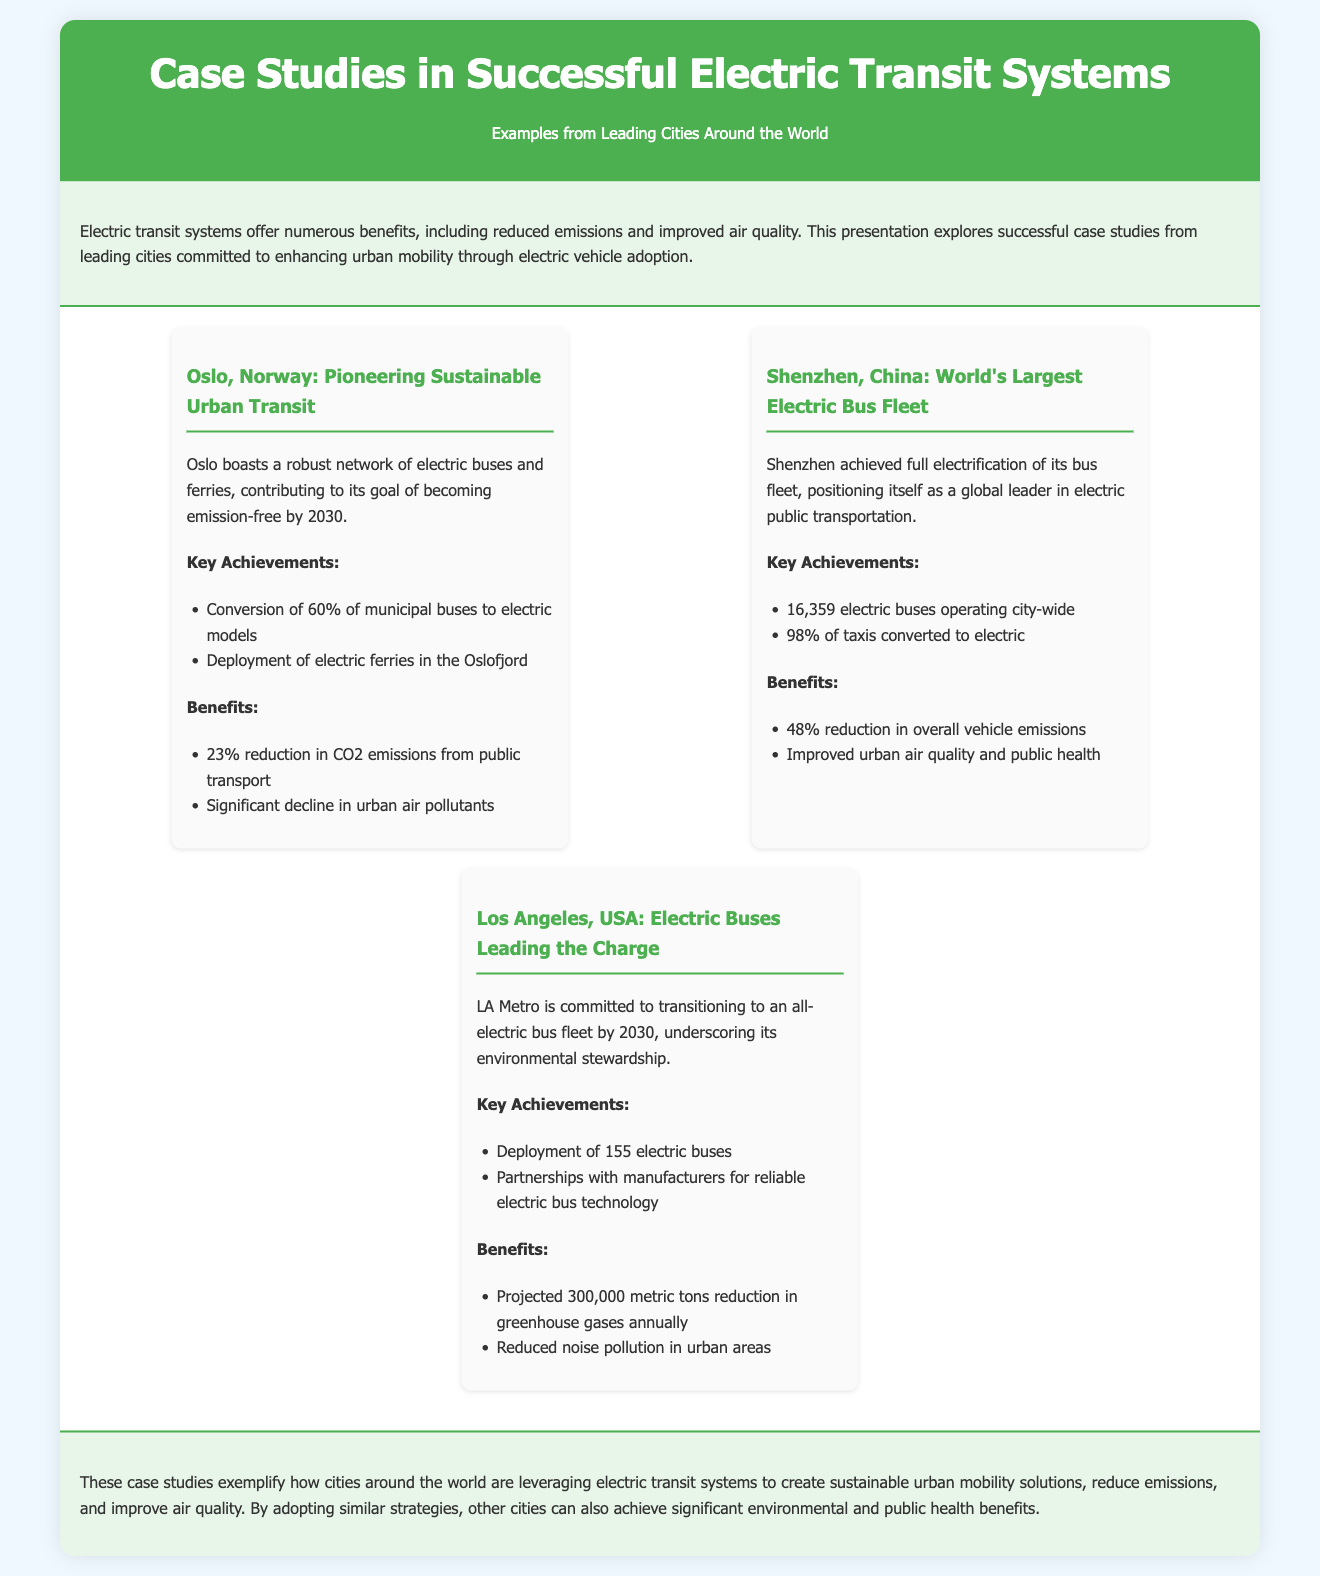what is the emission reduction goal for Oslo? Oslo aims to become emission-free by 2030, which indicates its commitment to reducing emissions.
Answer: 2030 how many electric buses are operating in Shenzhen? Shenzhen has 16,359 electric buses operating city-wide, showcasing the extent of its electrification efforts.
Answer: 16,359 what percentage of taxis in Shenzhen have been converted to electric? The document states that 98% of taxis in Shenzhen are electric, highlighting the city's dedication to electric transit.
Answer: 98% what is the projected annual reduction in greenhouse gases for LA Metro? The projected reduction in greenhouse gases is detailed in the document and amounts to a significant figure.
Answer: 300,000 metric tons which city has the largest electric bus fleet in the world? Shenzhen is identified as having the world's largest electric bus fleet, emphasizing its leadership in this area.
Answer: Shenzhen how many municipal buses in Oslo have been converted to electric? The document specifies that 60% of municipal buses in Oslo have been converted to electric models, indicating substantial progress.
Answer: 60% what benefit did Oslo achieve in terms of CO2 emissions from public transport? The document specifies the reduction achieved by Oslo in CO2 emissions, illustrating the environmental benefits of its transit system.
Answer: 23% what type of partnerships has LA Metro formed for its electric buses? LA Metro has formed partnerships with manufacturers, which is crucial for developing reliable electric bus technologies.
Answer: Partnerships with manufacturers what type of transit vehicles are deployed in the Oslofjord? The document mentions the deployment of electric ferries in the Oslofjord, indicating the scope of Oslo’s electric transit system.
Answer: Electric ferries 